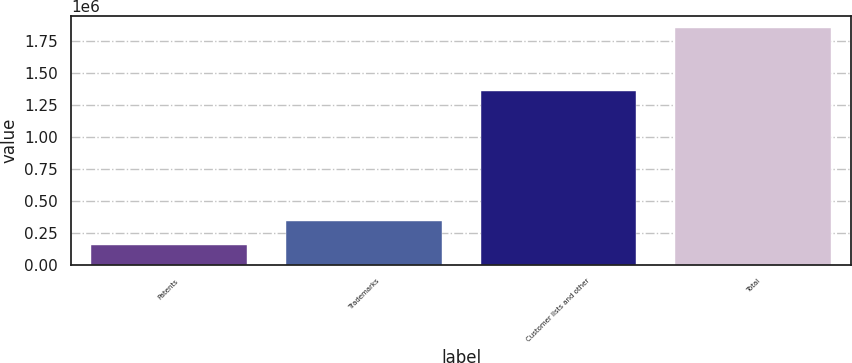Convert chart. <chart><loc_0><loc_0><loc_500><loc_500><bar_chart><fcel>Patents<fcel>Trademarks<fcel>Customer lists and other<fcel>Total<nl><fcel>150914<fcel>340805<fcel>1.36252e+06<fcel>1.85424e+06<nl></chart> 